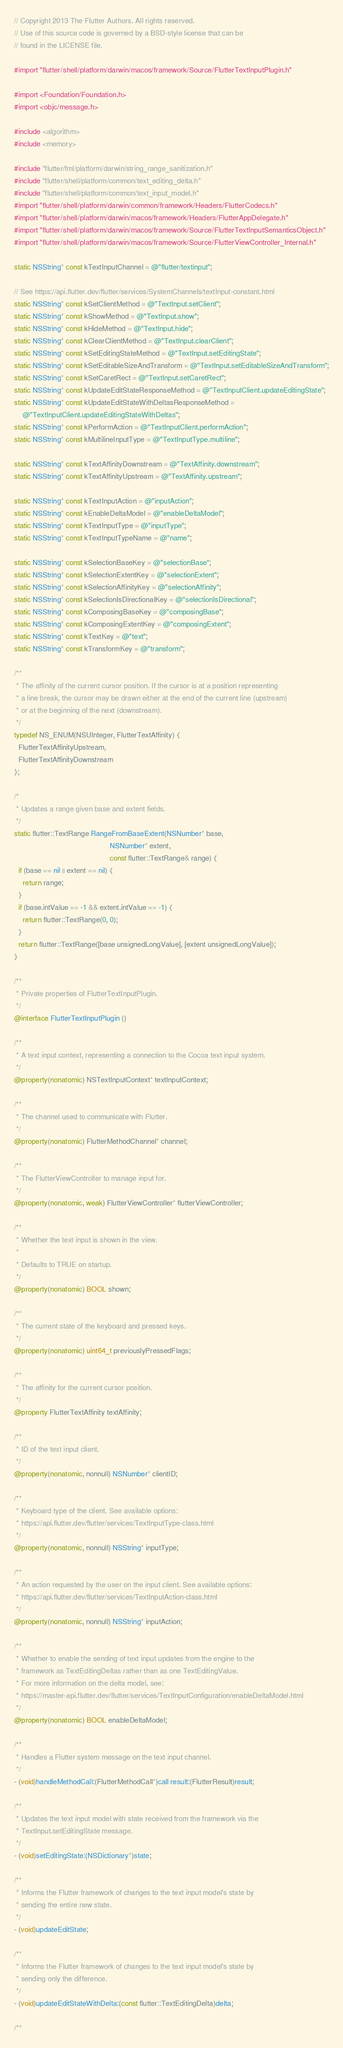Convert code to text. <code><loc_0><loc_0><loc_500><loc_500><_ObjectiveC_>// Copyright 2013 The Flutter Authors. All rights reserved.
// Use of this source code is governed by a BSD-style license that can be
// found in the LICENSE file.

#import "flutter/shell/platform/darwin/macos/framework/Source/FlutterTextInputPlugin.h"

#import <Foundation/Foundation.h>
#import <objc/message.h>

#include <algorithm>
#include <memory>

#include "flutter/fml/platform/darwin/string_range_sanitization.h"
#include "flutter/shell/platform/common/text_editing_delta.h"
#include "flutter/shell/platform/common/text_input_model.h"
#import "flutter/shell/platform/darwin/common/framework/Headers/FlutterCodecs.h"
#import "flutter/shell/platform/darwin/macos/framework/Headers/FlutterAppDelegate.h"
#import "flutter/shell/platform/darwin/macos/framework/Source/FlutterTextInputSemanticsObject.h"
#import "flutter/shell/platform/darwin/macos/framework/Source/FlutterViewController_Internal.h"

static NSString* const kTextInputChannel = @"flutter/textinput";

// See https://api.flutter.dev/flutter/services/SystemChannels/textInput-constant.html
static NSString* const kSetClientMethod = @"TextInput.setClient";
static NSString* const kShowMethod = @"TextInput.show";
static NSString* const kHideMethod = @"TextInput.hide";
static NSString* const kClearClientMethod = @"TextInput.clearClient";
static NSString* const kSetEditingStateMethod = @"TextInput.setEditingState";
static NSString* const kSetEditableSizeAndTransform = @"TextInput.setEditableSizeAndTransform";
static NSString* const kSetCaretRect = @"TextInput.setCaretRect";
static NSString* const kUpdateEditStateResponseMethod = @"TextInputClient.updateEditingState";
static NSString* const kUpdateEditStateWithDeltasResponseMethod =
    @"TextInputClient.updateEditingStateWithDeltas";
static NSString* const kPerformAction = @"TextInputClient.performAction";
static NSString* const kMultilineInputType = @"TextInputType.multiline";

static NSString* const kTextAffinityDownstream = @"TextAffinity.downstream";
static NSString* const kTextAffinityUpstream = @"TextAffinity.upstream";

static NSString* const kTextInputAction = @"inputAction";
static NSString* const kEnableDeltaModel = @"enableDeltaModel";
static NSString* const kTextInputType = @"inputType";
static NSString* const kTextInputTypeName = @"name";

static NSString* const kSelectionBaseKey = @"selectionBase";
static NSString* const kSelectionExtentKey = @"selectionExtent";
static NSString* const kSelectionAffinityKey = @"selectionAffinity";
static NSString* const kSelectionIsDirectionalKey = @"selectionIsDirectional";
static NSString* const kComposingBaseKey = @"composingBase";
static NSString* const kComposingExtentKey = @"composingExtent";
static NSString* const kTextKey = @"text";
static NSString* const kTransformKey = @"transform";

/**
 * The affinity of the current cursor position. If the cursor is at a position representing
 * a line break, the cursor may be drawn either at the end of the current line (upstream)
 * or at the beginning of the next (downstream).
 */
typedef NS_ENUM(NSUInteger, FlutterTextAffinity) {
  FlutterTextAffinityUpstream,
  FlutterTextAffinityDownstream
};

/*
 * Updates a range given base and extent fields.
 */
static flutter::TextRange RangeFromBaseExtent(NSNumber* base,
                                              NSNumber* extent,
                                              const flutter::TextRange& range) {
  if (base == nil || extent == nil) {
    return range;
  }
  if (base.intValue == -1 && extent.intValue == -1) {
    return flutter::TextRange(0, 0);
  }
  return flutter::TextRange([base unsignedLongValue], [extent unsignedLongValue]);
}

/**
 * Private properties of FlutterTextInputPlugin.
 */
@interface FlutterTextInputPlugin ()

/**
 * A text input context, representing a connection to the Cocoa text input system.
 */
@property(nonatomic) NSTextInputContext* textInputContext;

/**
 * The channel used to communicate with Flutter.
 */
@property(nonatomic) FlutterMethodChannel* channel;

/**
 * The FlutterViewController to manage input for.
 */
@property(nonatomic, weak) FlutterViewController* flutterViewController;

/**
 * Whether the text input is shown in the view.
 *
 * Defaults to TRUE on startup.
 */
@property(nonatomic) BOOL shown;

/**
 * The current state of the keyboard and pressed keys.
 */
@property(nonatomic) uint64_t previouslyPressedFlags;

/**
 * The affinity for the current cursor position.
 */
@property FlutterTextAffinity textAffinity;

/**
 * ID of the text input client.
 */
@property(nonatomic, nonnull) NSNumber* clientID;

/**
 * Keyboard type of the client. See available options:
 * https://api.flutter.dev/flutter/services/TextInputType-class.html
 */
@property(nonatomic, nonnull) NSString* inputType;

/**
 * An action requested by the user on the input client. See available options:
 * https://api.flutter.dev/flutter/services/TextInputAction-class.html
 */
@property(nonatomic, nonnull) NSString* inputAction;

/**
 * Whether to enable the sending of text input updates from the engine to the
 * framework as TextEditingDeltas rather than as one TextEditingValue.
 * For more information on the delta model, see:
 * https://master-api.flutter.dev/flutter/services/TextInputConfiguration/enableDeltaModel.html
 */
@property(nonatomic) BOOL enableDeltaModel;

/**
 * Handles a Flutter system message on the text input channel.
 */
- (void)handleMethodCall:(FlutterMethodCall*)call result:(FlutterResult)result;

/**
 * Updates the text input model with state received from the framework via the
 * TextInput.setEditingState message.
 */
- (void)setEditingState:(NSDictionary*)state;

/**
 * Informs the Flutter framework of changes to the text input model's state by
 * sending the entire new state.
 */
- (void)updateEditState;

/**
 * Informs the Flutter framework of changes to the text input model's state by
 * sending only the difference.
 */
- (void)updateEditStateWithDelta:(const flutter::TextEditingDelta)delta;

/**</code> 